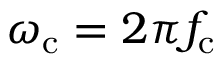<formula> <loc_0><loc_0><loc_500><loc_500>\omega _ { c } = 2 \pi f _ { c }</formula> 